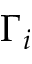Convert formula to latex. <formula><loc_0><loc_0><loc_500><loc_500>\Gamma _ { i }</formula> 